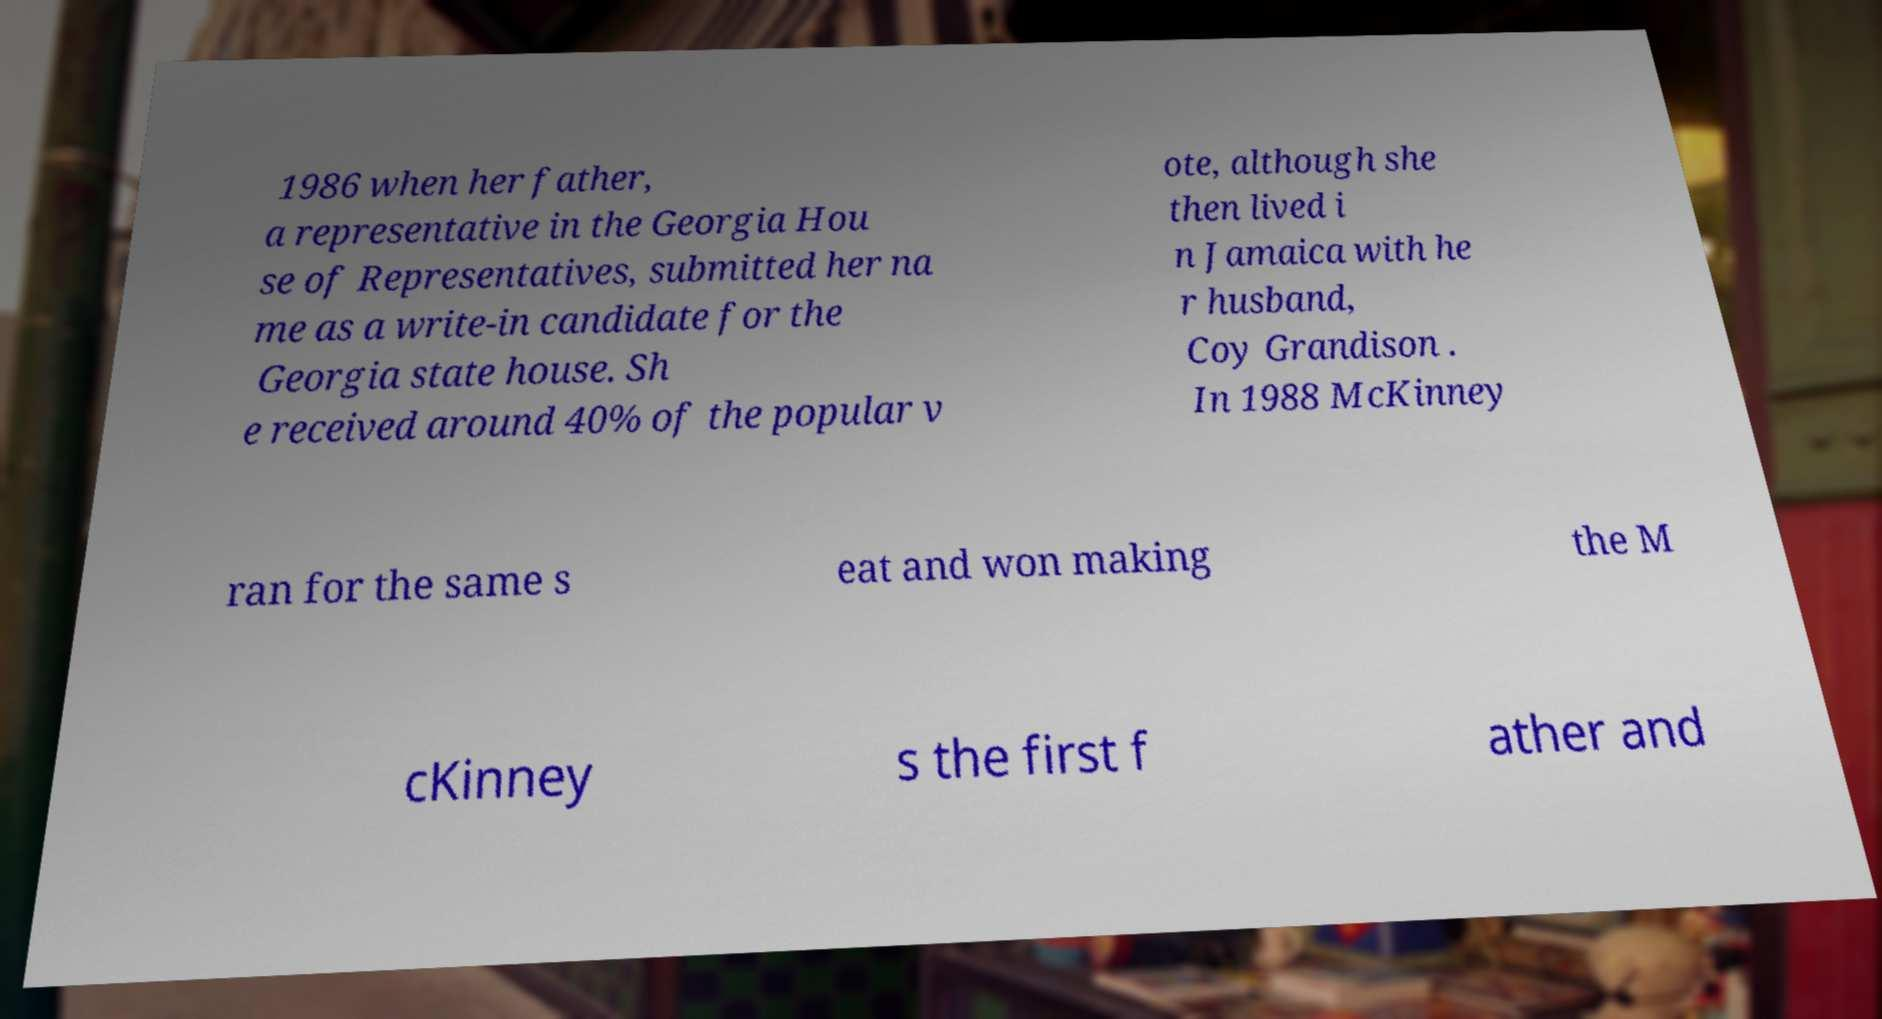I need the written content from this picture converted into text. Can you do that? 1986 when her father, a representative in the Georgia Hou se of Representatives, submitted her na me as a write-in candidate for the Georgia state house. Sh e received around 40% of the popular v ote, although she then lived i n Jamaica with he r husband, Coy Grandison . In 1988 McKinney ran for the same s eat and won making the M cKinney s the first f ather and 